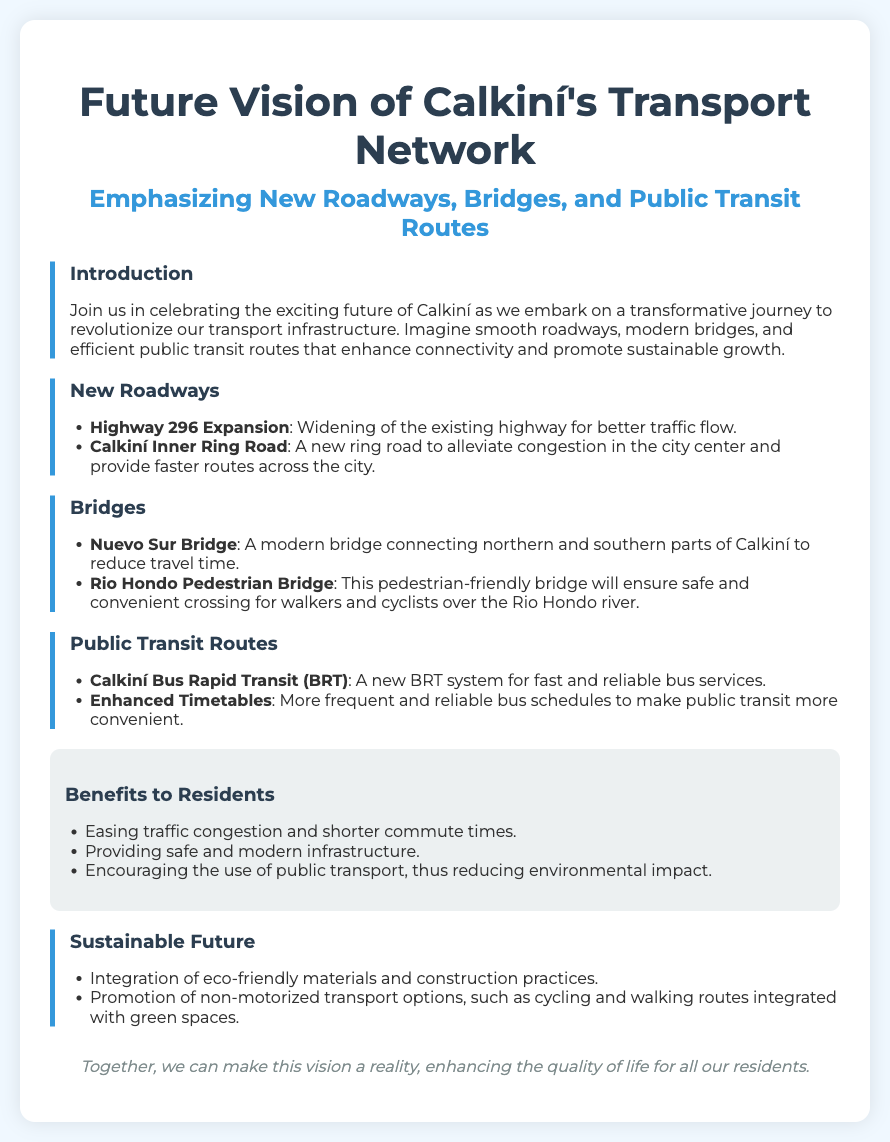What is the title of the poster? The title is prominently displayed at the top of the poster, indicating the main focus of the content.
Answer: Future Vision of Calkiní's Transport Network What new public transit system is mentioned? The document highlights a specific public transit initiative aimed at improving bus services in Calkiní.
Answer: Calkiní Bus Rapid Transit (BRT) What type of bridge is the Rio Hondo Pedestrian Bridge? The document specifies the function of this bridge in terms of accessibility for certain types of users.
Answer: Pedestrian-friendly What highway is being expanded? The document lists a specific highway that is undergoing improvements to enhance traffic flow.
Answer: Highway 296 What is one benefit to residents mentioned? This benefit is one of the outcomes of the planned infrastructure developments aimed at improving everyday experiences.
Answer: Easing traffic congestion How many new roadways are emphasized in the document? The document includes a mention of distinct new roadways, which indicates the number of specific projects.
Answer: Two What is promoted alongside non-motorized transport options? The document discusses a combination of transportation modes and their associated environments to enhance urban mobility.
Answer: Green spaces What is the focus of the "Sustainable Future" section? This section elaborates on the construction practices and transportation options that are eco-friendly.
Answer: Eco-friendly materials and construction practices What is a key component of the Calkiní Inner Ring Road? The document states what this new roadway is specifically aimed at solving in Calkiní.
Answer: Alleviating congestion 